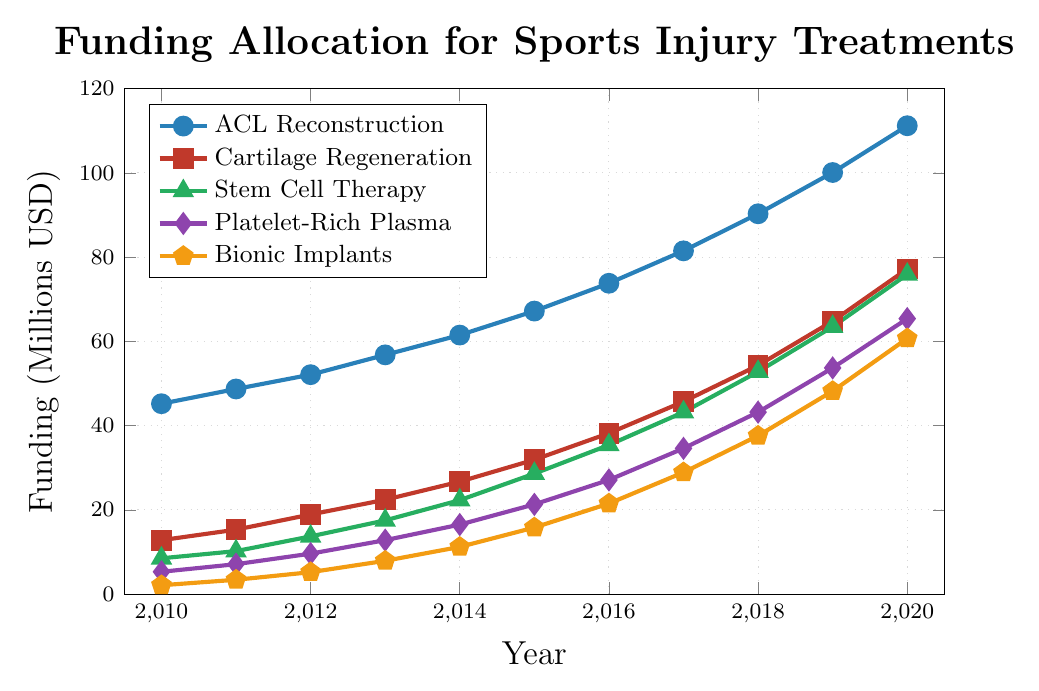What year did the funding for ACL Reconstruction surpass 100 million USD? To answer this, find the year in the figure where the line representing ACL Reconstruction (blue) crosses the 100 million USD mark on the y-axis. The figure shows it reaching 100.1 million USD in 2019.
Answer: 2019 Compare the funding growth for Cartilage Regeneration and Stem Cell Therapy between 2010 and 2020. Which had a higher increase? Calculate the differences for both by subtracting the 2010 values from the 2020 values. Cartilage Regeneration grew from 12.8 to 77.2 million USD (64.4 million increase), and Stem Cell Therapy grew from 8.5 to 75.9 million USD (67.4 million increase). Hence, Stem Cell Therapy had a higher increase.
Answer: Stem Cell Therapy What is the combined funding for Platelet-Rich Plasma and Bionic Implants in 2015? To get the combined funding, add the values of Platelet-Rich Plasma (21.3 million USD) and Bionic Implants (15.8 million USD) for 2015. 21.3 + 15.8 = 37.1 million USD.
Answer: 37.1 million USD In which year did the funding for Stem Cell Therapy first exceed 50 million USD? Look for the earliest year where the funding for Stem Cell Therapy (green line) crosses the 50 million USD mark. According to the figure, this occurs in 2018 when it reaches 52.8 million USD.
Answer: 2018 By how much did the funding for Platelet-Rich Plasma increase from 2010 to 2013? Subtract the 2010 value of Platelet-Rich Plasma (5.3 million USD) from its 2013 value (12.8 million USD). 12.8 - 5.3 = 7.5 million USD.
Answer: 7.5 million USD Which treatment had the lowest funding in 2012, and what was the amount? Find the lowest point on the figure for 2012. The lowest line is for Bionic Implants (orange line), which had 5.2 million USD.
Answer: Bionic Implants, 5.2 million USD By how much did the funding for ACL Reconstruction increase between 2015 and 2020? Subtract the funding in 2015 (67.2 million USD) from the funding in 2020 (111.2 million USD). 111.2 - 67.2 = 44 million USD.
Answer: 44 million USD How many treatments had their funding exceed 60 million USD by 2020? From the figure, identify the treatments with funding above 60 million USD in 2020. These are ACL Reconstruction (111.2), Cartilage Regeneration (77.2), Stem Cell Therapy (75.9), and Platelet-Rich Plasma (65.4). Four treatments meet this criterion.
Answer: 4 